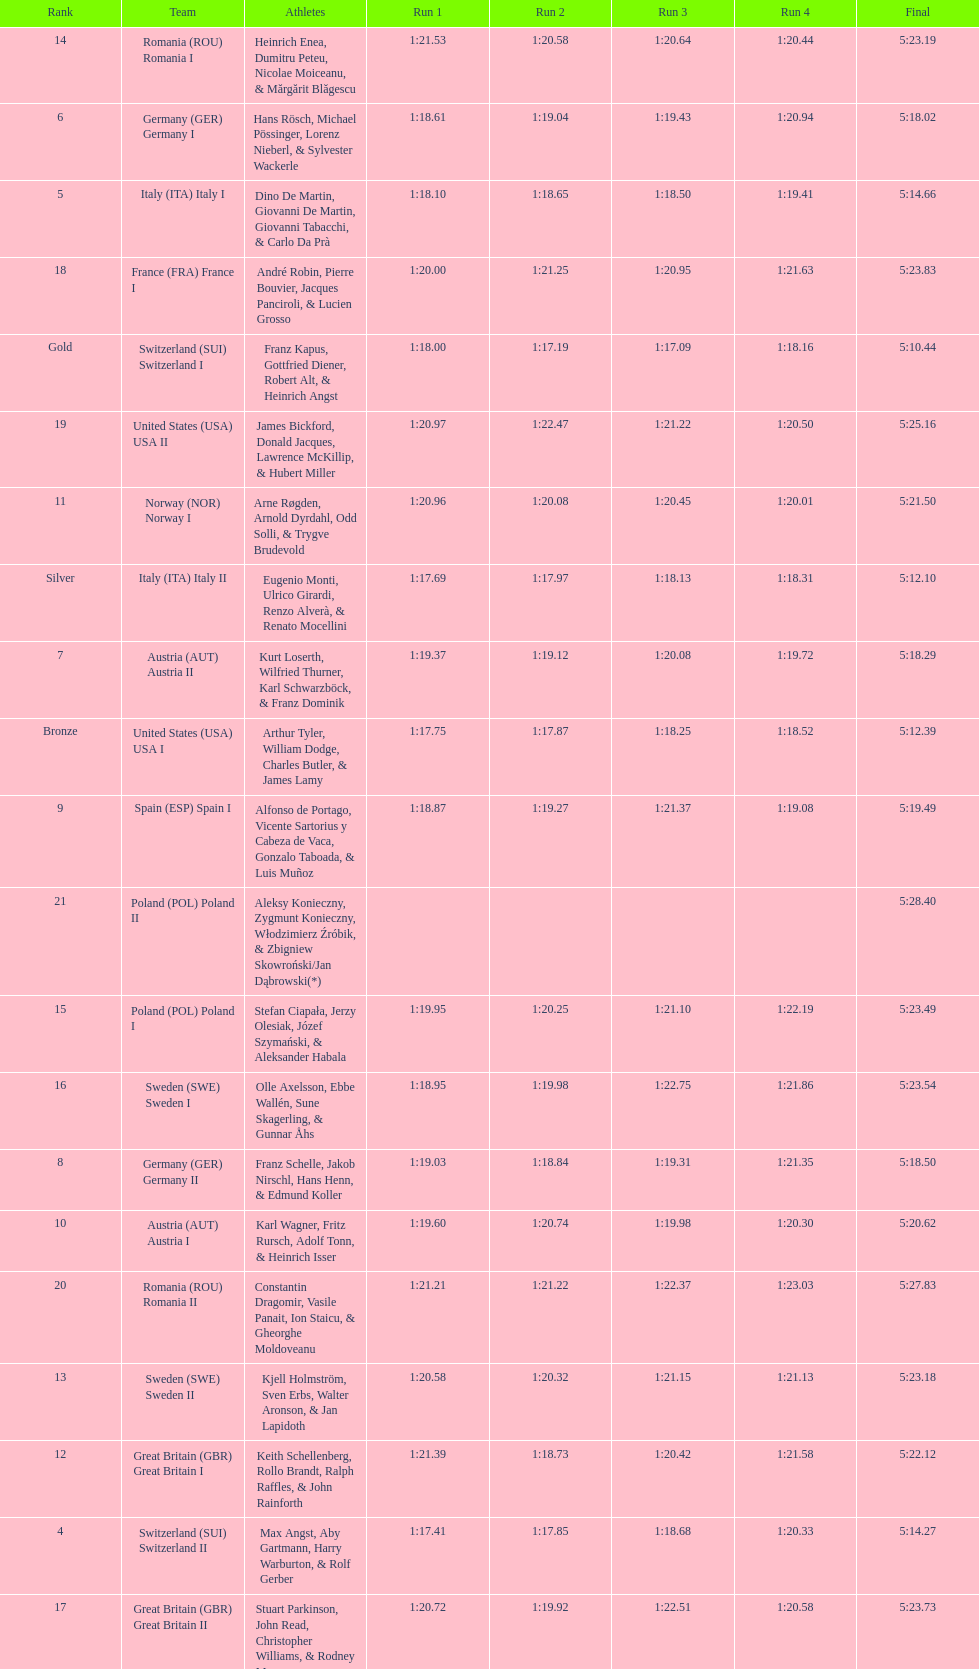Could you parse the entire table as a dict? {'header': ['Rank', 'Team', 'Athletes', 'Run 1', 'Run 2', 'Run 3', 'Run 4', 'Final'], 'rows': [['14', 'Romania\xa0(ROU) Romania I', 'Heinrich Enea, Dumitru Peteu, Nicolae Moiceanu, & Mărgărit Blăgescu', '1:21.53', '1:20.58', '1:20.64', '1:20.44', '5:23.19'], ['6', 'Germany\xa0(GER) Germany I', 'Hans Rösch, Michael Pössinger, Lorenz Nieberl, & Sylvester Wackerle', '1:18.61', '1:19.04', '1:19.43', '1:20.94', '5:18.02'], ['5', 'Italy\xa0(ITA) Italy I', 'Dino De Martin, Giovanni De Martin, Giovanni Tabacchi, & Carlo Da Prà', '1:18.10', '1:18.65', '1:18.50', '1:19.41', '5:14.66'], ['18', 'France\xa0(FRA) France I', 'André Robin, Pierre Bouvier, Jacques Panciroli, & Lucien Grosso', '1:20.00', '1:21.25', '1:20.95', '1:21.63', '5:23.83'], ['Gold', 'Switzerland\xa0(SUI) Switzerland I', 'Franz Kapus, Gottfried Diener, Robert Alt, & Heinrich Angst', '1:18.00', '1:17.19', '1:17.09', '1:18.16', '5:10.44'], ['19', 'United States\xa0(USA) USA II', 'James Bickford, Donald Jacques, Lawrence McKillip, & Hubert Miller', '1:20.97', '1:22.47', '1:21.22', '1:20.50', '5:25.16'], ['11', 'Norway\xa0(NOR) Norway I', 'Arne Røgden, Arnold Dyrdahl, Odd Solli, & Trygve Brudevold', '1:20.96', '1:20.08', '1:20.45', '1:20.01', '5:21.50'], ['Silver', 'Italy\xa0(ITA) Italy II', 'Eugenio Monti, Ulrico Girardi, Renzo Alverà, & Renato Mocellini', '1:17.69', '1:17.97', '1:18.13', '1:18.31', '5:12.10'], ['7', 'Austria\xa0(AUT) Austria II', 'Kurt Loserth, Wilfried Thurner, Karl Schwarzböck, & Franz Dominik', '1:19.37', '1:19.12', '1:20.08', '1:19.72', '5:18.29'], ['Bronze', 'United States\xa0(USA) USA I', 'Arthur Tyler, William Dodge, Charles Butler, & James Lamy', '1:17.75', '1:17.87', '1:18.25', '1:18.52', '5:12.39'], ['9', 'Spain\xa0(ESP) Spain I', 'Alfonso de Portago, Vicente Sartorius y Cabeza de Vaca, Gonzalo Taboada, & Luis Muñoz', '1:18.87', '1:19.27', '1:21.37', '1:19.08', '5:19.49'], ['21', 'Poland\xa0(POL) Poland II', 'Aleksy Konieczny, Zygmunt Konieczny, Włodzimierz Źróbik, & Zbigniew Skowroński/Jan Dąbrowski(*)', '', '', '', '', '5:28.40'], ['15', 'Poland\xa0(POL) Poland I', 'Stefan Ciapała, Jerzy Olesiak, Józef Szymański, & Aleksander Habala', '1:19.95', '1:20.25', '1:21.10', '1:22.19', '5:23.49'], ['16', 'Sweden\xa0(SWE) Sweden I', 'Olle Axelsson, Ebbe Wallén, Sune Skagerling, & Gunnar Åhs', '1:18.95', '1:19.98', '1:22.75', '1:21.86', '5:23.54'], ['8', 'Germany\xa0(GER) Germany II', 'Franz Schelle, Jakob Nirschl, Hans Henn, & Edmund Koller', '1:19.03', '1:18.84', '1:19.31', '1:21.35', '5:18.50'], ['10', 'Austria\xa0(AUT) Austria I', 'Karl Wagner, Fritz Rursch, Adolf Tonn, & Heinrich Isser', '1:19.60', '1:20.74', '1:19.98', '1:20.30', '5:20.62'], ['20', 'Romania\xa0(ROU) Romania II', 'Constantin Dragomir, Vasile Panait, Ion Staicu, & Gheorghe Moldoveanu', '1:21.21', '1:21.22', '1:22.37', '1:23.03', '5:27.83'], ['13', 'Sweden\xa0(SWE) Sweden II', 'Kjell Holmström, Sven Erbs, Walter Aronson, & Jan Lapidoth', '1:20.58', '1:20.32', '1:21.15', '1:21.13', '5:23.18'], ['12', 'Great Britain\xa0(GBR) Great Britain I', 'Keith Schellenberg, Rollo Brandt, Ralph Raffles, & John Rainforth', '1:21.39', '1:18.73', '1:20.42', '1:21.58', '5:22.12'], ['4', 'Switzerland\xa0(SUI) Switzerland II', 'Max Angst, Aby Gartmann, Harry Warburton, & Rolf Gerber', '1:17.41', '1:17.85', '1:18.68', '1:20.33', '5:14.27'], ['17', 'Great Britain\xa0(GBR) Great Britain II', 'Stuart Parkinson, John Read, Christopher Williams, & Rodney Mann', '1:20.72', '1:19.92', '1:22.51', '1:20.58', '5:23.73']]} Which team won the most runs? Switzerland. 